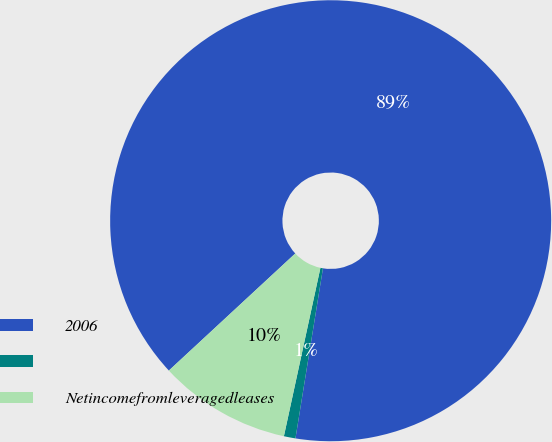Convert chart to OTSL. <chart><loc_0><loc_0><loc_500><loc_500><pie_chart><fcel>2006<fcel>Unnamed: 1<fcel>Netincomefromleveragedleases<nl><fcel>89.45%<fcel>0.85%<fcel>9.71%<nl></chart> 